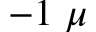<formula> <loc_0><loc_0><loc_500><loc_500>- 1 \mu</formula> 